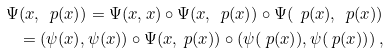Convert formula to latex. <formula><loc_0><loc_0><loc_500><loc_500>\Psi ( x , \ p ( x ) ) = \Psi ( x , x ) \circ \Psi ( x , \ p ( x ) ) \circ \Psi ( \ p ( x ) , \ p ( x ) ) \\ = ( \psi ( x ) , \psi ( x ) ) \circ \Psi ( x , \ p ( x ) ) \circ ( \psi ( \ p ( x ) ) , \psi ( \ p ( x ) ) ) \, ,</formula> 